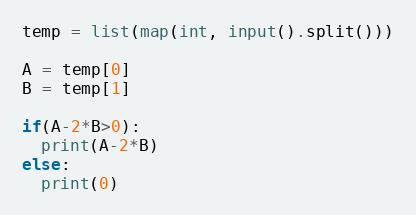<code> <loc_0><loc_0><loc_500><loc_500><_Python_>temp = list(map(int, input().split()))

A = temp[0]
B = temp[1]

if(A-2*B>0):
  print(A-2*B)
else:
  print(0)</code> 